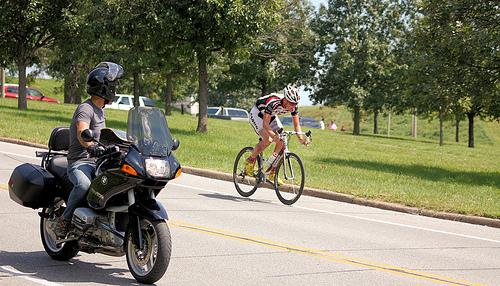Question: where are they riding?
Choices:
A. On a backroad.
B. On a path.
C. Through a yard.
D. On a highway.
Answer with the letter. Answer: D Question: when will the bicyclist stop?
Choices:
A. At the stop sign.
B. In an hour.
C. After the race.
D. After the exercise is over.
Answer with the letter. Answer: D Question: how much faster can the motorcycle go?
Choices:
A. Much faster than the bicycle.
B. Faster than a jogger.
C. Faster than a moped.
D. Faster than a horse.
Answer with the letter. Answer: A 